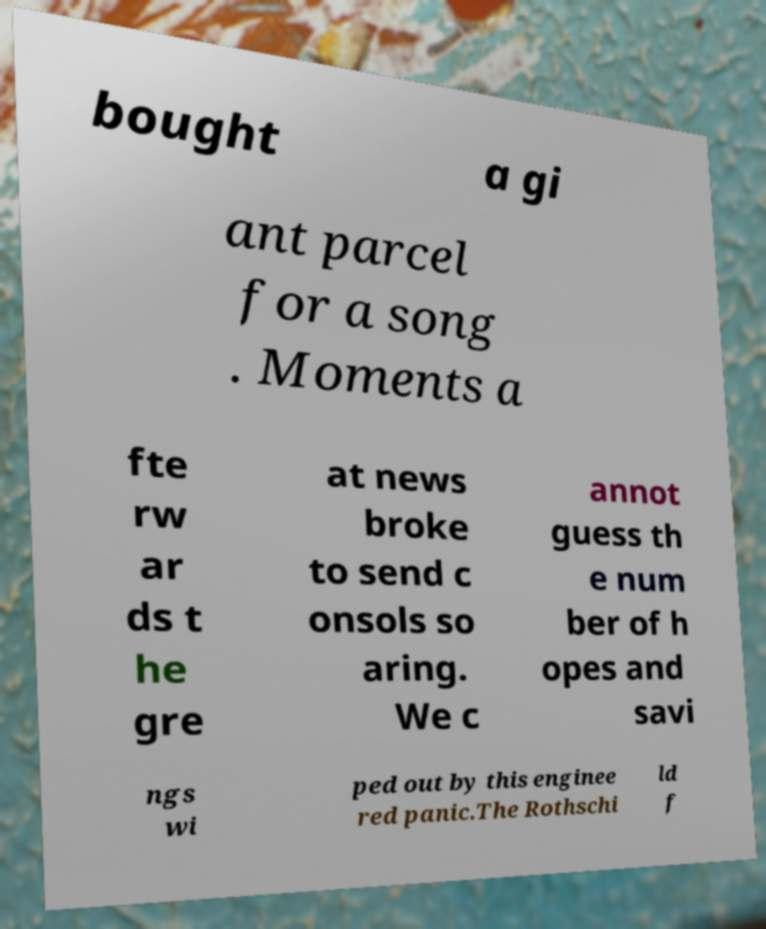For documentation purposes, I need the text within this image transcribed. Could you provide that? bought a gi ant parcel for a song . Moments a fte rw ar ds t he gre at news broke to send c onsols so aring. We c annot guess th e num ber of h opes and savi ngs wi ped out by this enginee red panic.The Rothschi ld f 